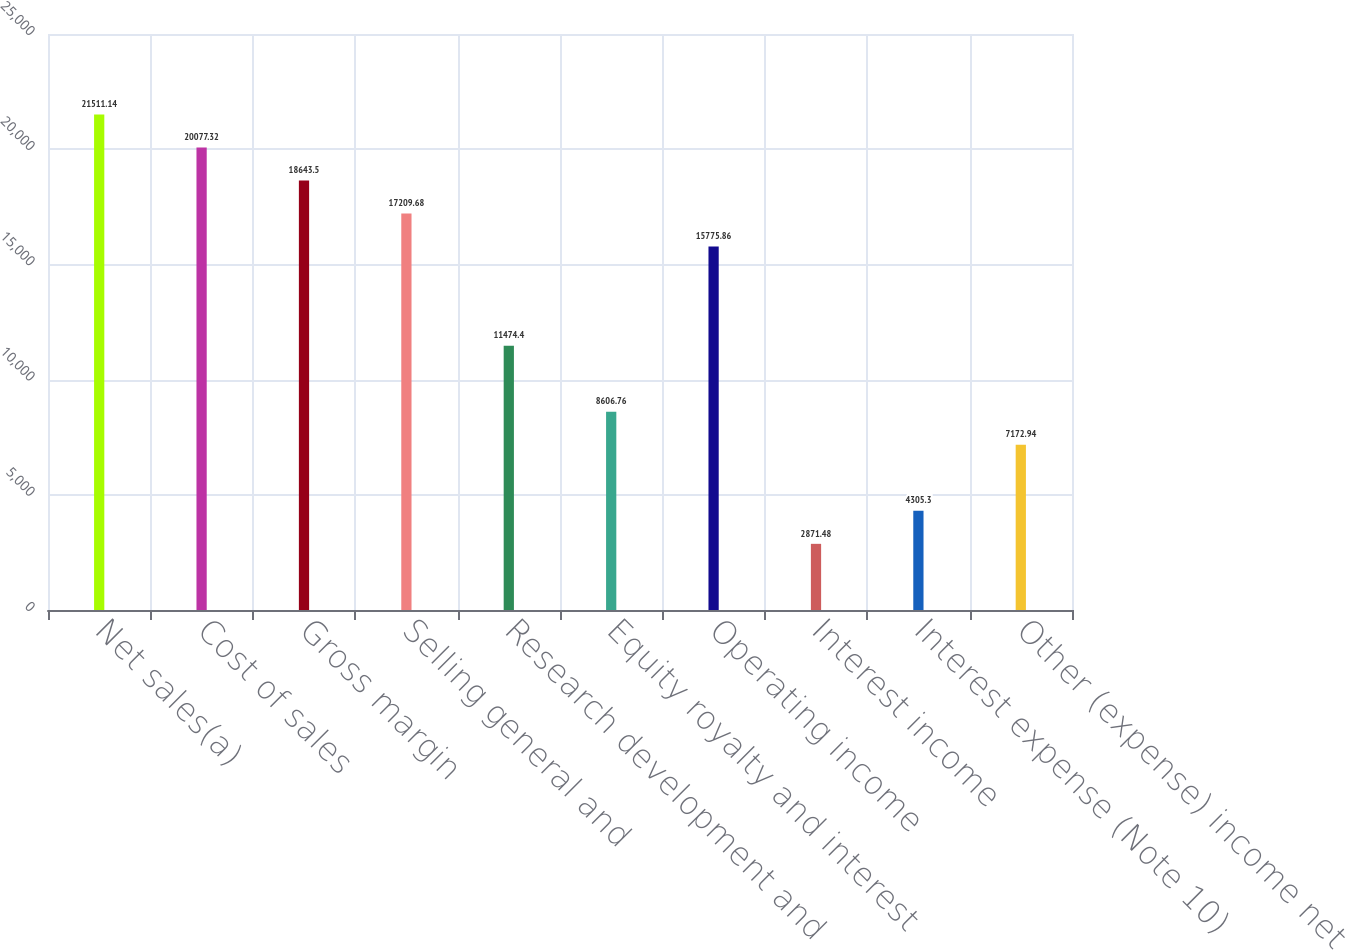<chart> <loc_0><loc_0><loc_500><loc_500><bar_chart><fcel>Net sales(a)<fcel>Cost of sales<fcel>Gross margin<fcel>Selling general and<fcel>Research development and<fcel>Equity royalty and interest<fcel>Operating income<fcel>Interest income<fcel>Interest expense (Note 10)<fcel>Other (expense) income net<nl><fcel>21511.1<fcel>20077.3<fcel>18643.5<fcel>17209.7<fcel>11474.4<fcel>8606.76<fcel>15775.9<fcel>2871.48<fcel>4305.3<fcel>7172.94<nl></chart> 